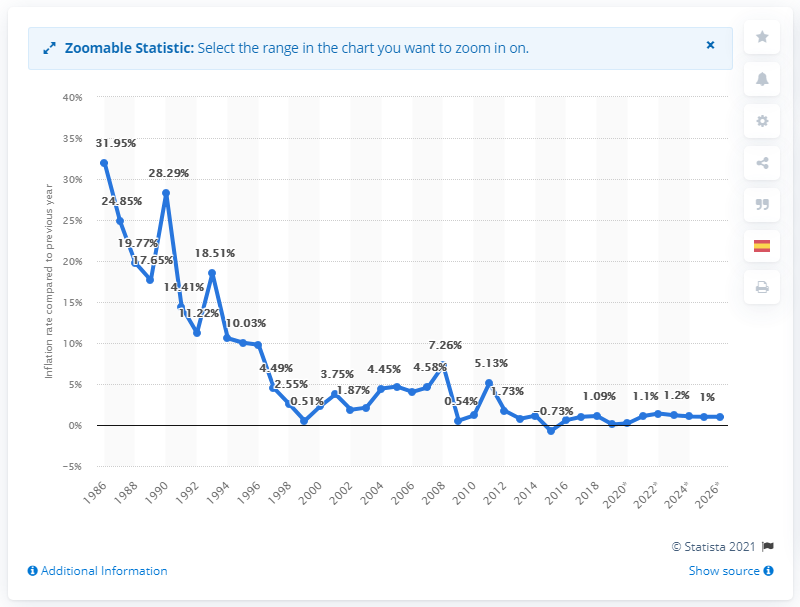Point out several critical features in this image. The inflation rate in El Salvador in 2019 was 0.07%. 